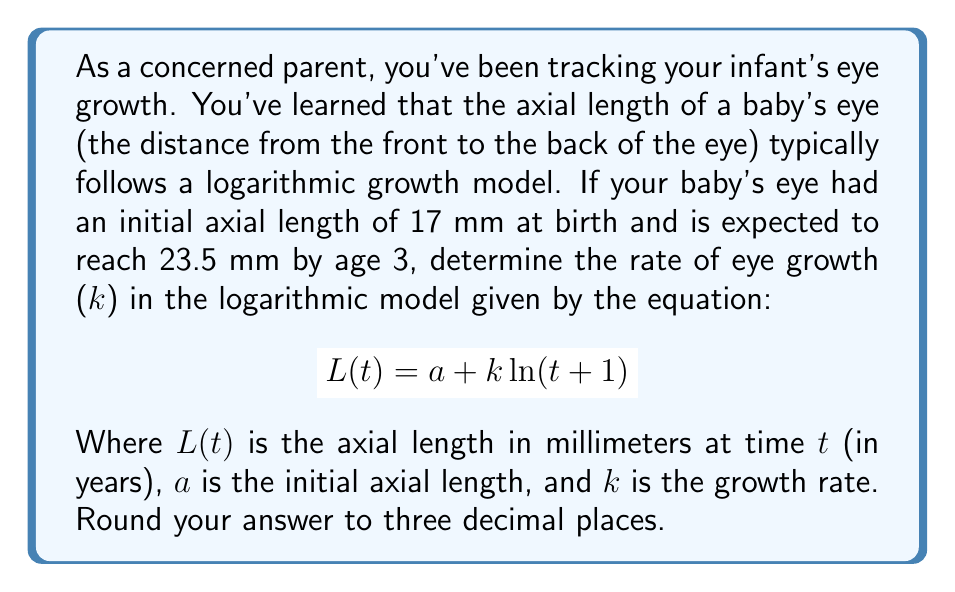Give your solution to this math problem. To solve this problem, we'll use the logarithmic growth model equation and the given information:

1) Initial conditions:
   At birth (t = 0): L(0) = 17 mm
   At 3 years (t = 3): L(3) = 23.5 mm

2) We can set up two equations using the model:
   $$ 17 = a + k \ln(0+1) $$
   $$ 23.5 = a + k \ln(3+1) $$

3) From the first equation, we can deduce that a = 17 (since ln(1) = 0)

4) Substituting this into the second equation:
   $$ 23.5 = 17 + k \ln(4) $$

5) Solving for k:
   $$ 6.5 = k \ln(4) $$
   $$ k = \frac{6.5}{\ln(4)} $$

6) Calculate the value:
   $$ k = \frac{6.5}{\ln(4)} \approx 4.684 $$

7) Rounding to three decimal places:
   k ≈ 4.684 mm

This value represents the rate of eye growth in the logarithmic model, indicating how quickly the eye grows over time.
Answer: 4.684 mm 